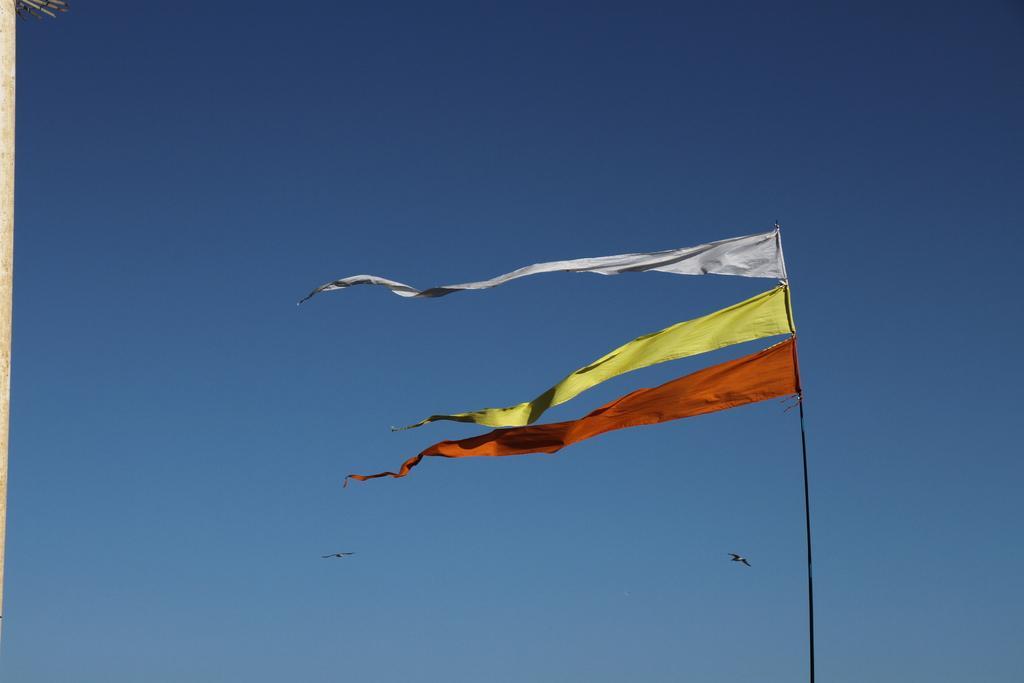Please provide a concise description of this image. In this picture there is a flag. In the back there are two birds which are flying in the sky. At the top there is a sky. On the left it might be pole or wall. 